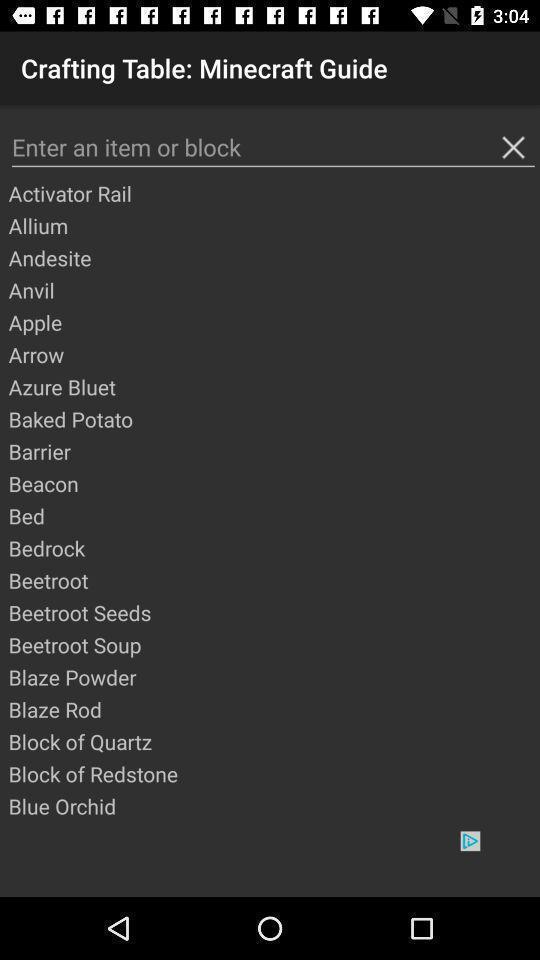Please provide a description for this image. Search bar to enter item and with few options. 